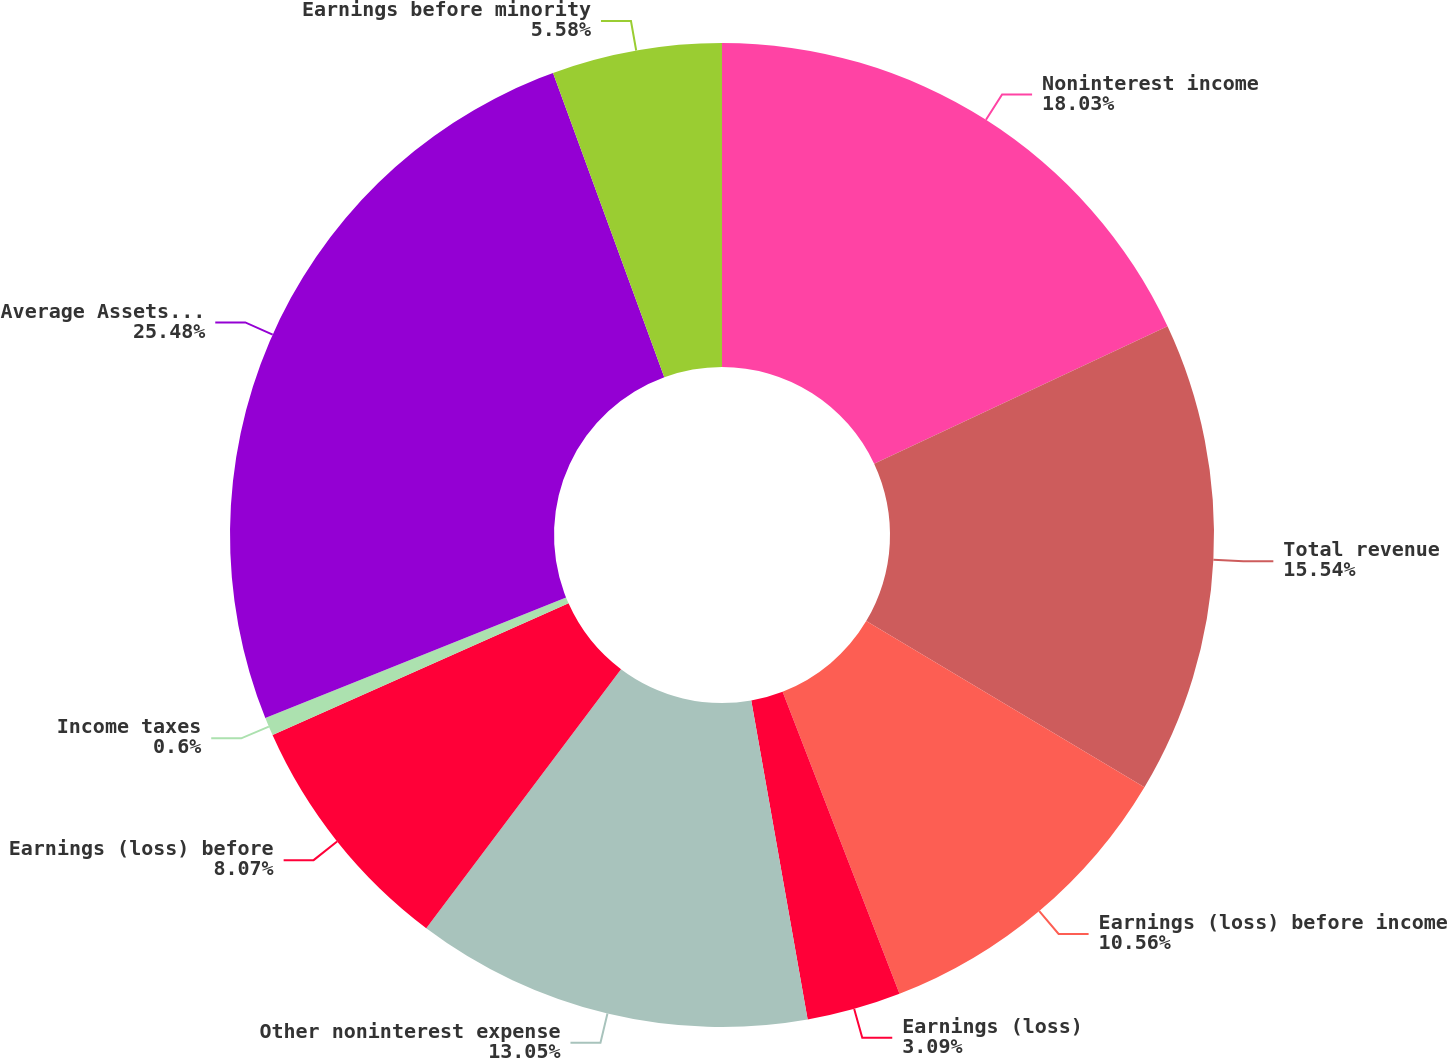Convert chart. <chart><loc_0><loc_0><loc_500><loc_500><pie_chart><fcel>Noninterest income<fcel>Total revenue<fcel>Earnings (loss) before income<fcel>Earnings (loss)<fcel>Other noninterest expense<fcel>Earnings (loss) before<fcel>Income taxes<fcel>Average Assets (a)<fcel>Earnings before minority<nl><fcel>18.03%<fcel>15.54%<fcel>10.56%<fcel>3.09%<fcel>13.05%<fcel>8.07%<fcel>0.6%<fcel>25.49%<fcel>5.58%<nl></chart> 